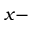<formula> <loc_0><loc_0><loc_500><loc_500>x -</formula> 